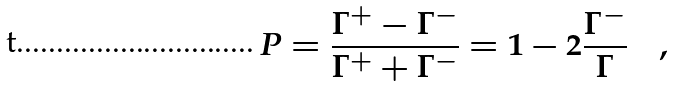Convert formula to latex. <formula><loc_0><loc_0><loc_500><loc_500>P = { \frac { \Gamma ^ { + } - \Gamma ^ { - } } { \Gamma ^ { + } + \Gamma ^ { - } } } = 1 - 2 { \frac { \Gamma ^ { - } } { \Gamma } } \quad ,</formula> 